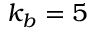<formula> <loc_0><loc_0><loc_500><loc_500>k _ { b } = 5</formula> 